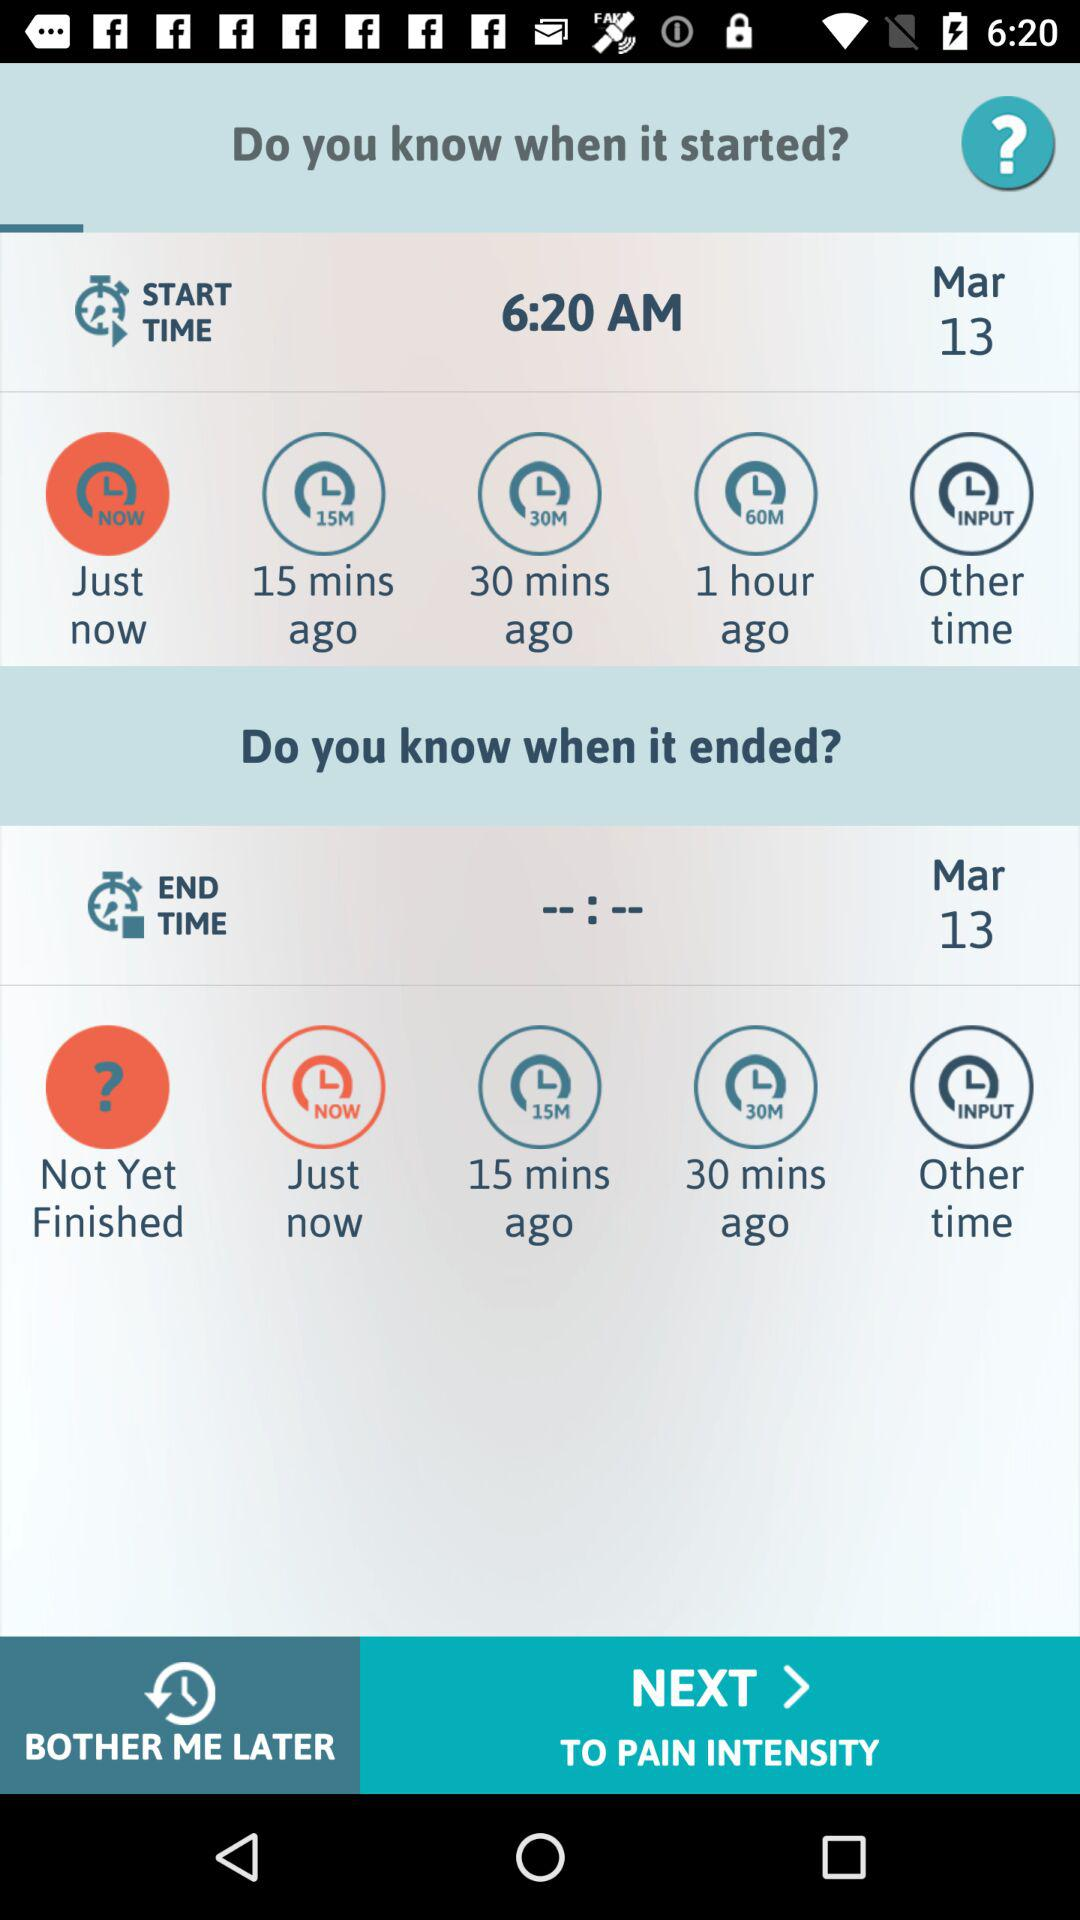What is the start date? The start date is March 13. 